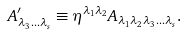<formula> <loc_0><loc_0><loc_500><loc_500>A ^ { \prime } _ { \lambda _ { 3 } \dots \lambda _ { s } } \equiv \eta ^ { \lambda _ { 1 } \lambda _ { 2 } } A _ { \lambda _ { 1 } \lambda _ { 2 } \lambda _ { 3 } \dots \lambda _ { s } } .</formula> 